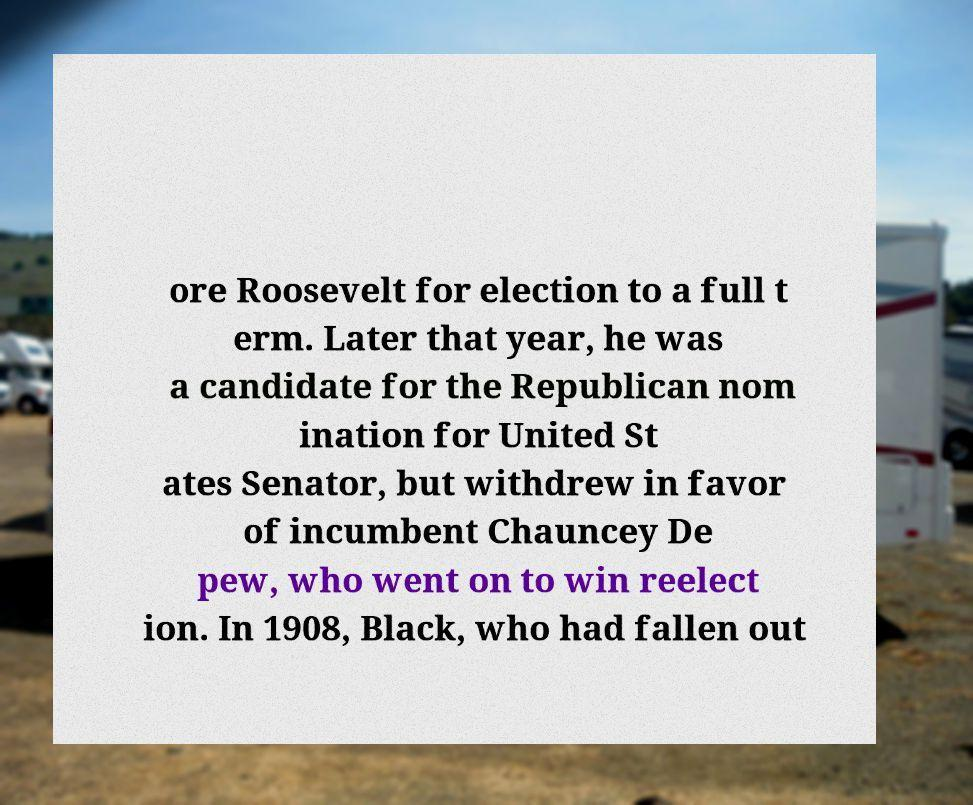Please read and relay the text visible in this image. What does it say? ore Roosevelt for election to a full t erm. Later that year, he was a candidate for the Republican nom ination for United St ates Senator, but withdrew in favor of incumbent Chauncey De pew, who went on to win reelect ion. In 1908, Black, who had fallen out 